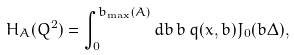<formula> <loc_0><loc_0><loc_500><loc_500>H _ { A } ( Q ^ { 2 } ) = \int _ { 0 } ^ { b _ { \max } ( A ) } d b \, b \, q ( x , b ) J _ { 0 } ( b \Delta ) ,</formula> 